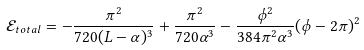Convert formula to latex. <formula><loc_0><loc_0><loc_500><loc_500>\mathcal { E } _ { t o t a l } = - \frac { \pi ^ { 2 } } { 7 2 0 ( L - \alpha ) ^ { 3 } } + \frac { \pi ^ { 2 } } { 7 2 0 \alpha ^ { 3 } } - \frac { \phi ^ { 2 } } { 3 8 4 \pi ^ { 2 } \alpha ^ { 3 } } ( \phi - 2 \pi ) ^ { 2 }</formula> 